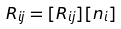Convert formula to latex. <formula><loc_0><loc_0><loc_500><loc_500>R _ { i j } = [ R _ { i j } ] [ n _ { i } ]</formula> 